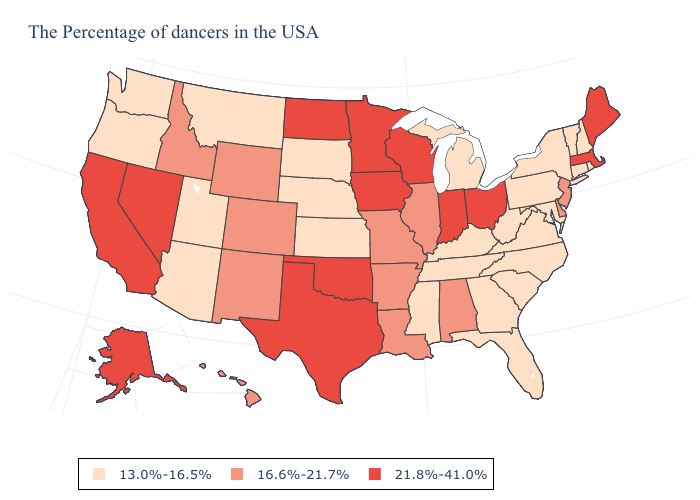Does Washington have the lowest value in the West?
Answer briefly. Yes. Name the states that have a value in the range 21.8%-41.0%?
Answer briefly. Maine, Massachusetts, Ohio, Indiana, Wisconsin, Minnesota, Iowa, Oklahoma, Texas, North Dakota, Nevada, California, Alaska. Among the states that border Iowa , which have the lowest value?
Concise answer only. Nebraska, South Dakota. What is the highest value in the MidWest ?
Answer briefly. 21.8%-41.0%. What is the lowest value in states that border New Hampshire?
Be succinct. 13.0%-16.5%. What is the lowest value in the USA?
Answer briefly. 13.0%-16.5%. How many symbols are there in the legend?
Be succinct. 3. Does Hawaii have the same value as Minnesota?
Quick response, please. No. What is the value of Oklahoma?
Write a very short answer. 21.8%-41.0%. Name the states that have a value in the range 13.0%-16.5%?
Quick response, please. Rhode Island, New Hampshire, Vermont, Connecticut, New York, Maryland, Pennsylvania, Virginia, North Carolina, South Carolina, West Virginia, Florida, Georgia, Michigan, Kentucky, Tennessee, Mississippi, Kansas, Nebraska, South Dakota, Utah, Montana, Arizona, Washington, Oregon. Does the map have missing data?
Keep it brief. No. Does Ohio have the highest value in the MidWest?
Be succinct. Yes. What is the value of Washington?
Write a very short answer. 13.0%-16.5%. What is the value of Washington?
Write a very short answer. 13.0%-16.5%. 